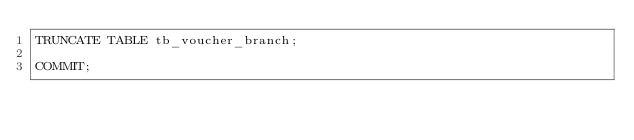<code> <loc_0><loc_0><loc_500><loc_500><_SQL_>TRUNCATE TABLE tb_voucher_branch;

COMMIT;
</code> 